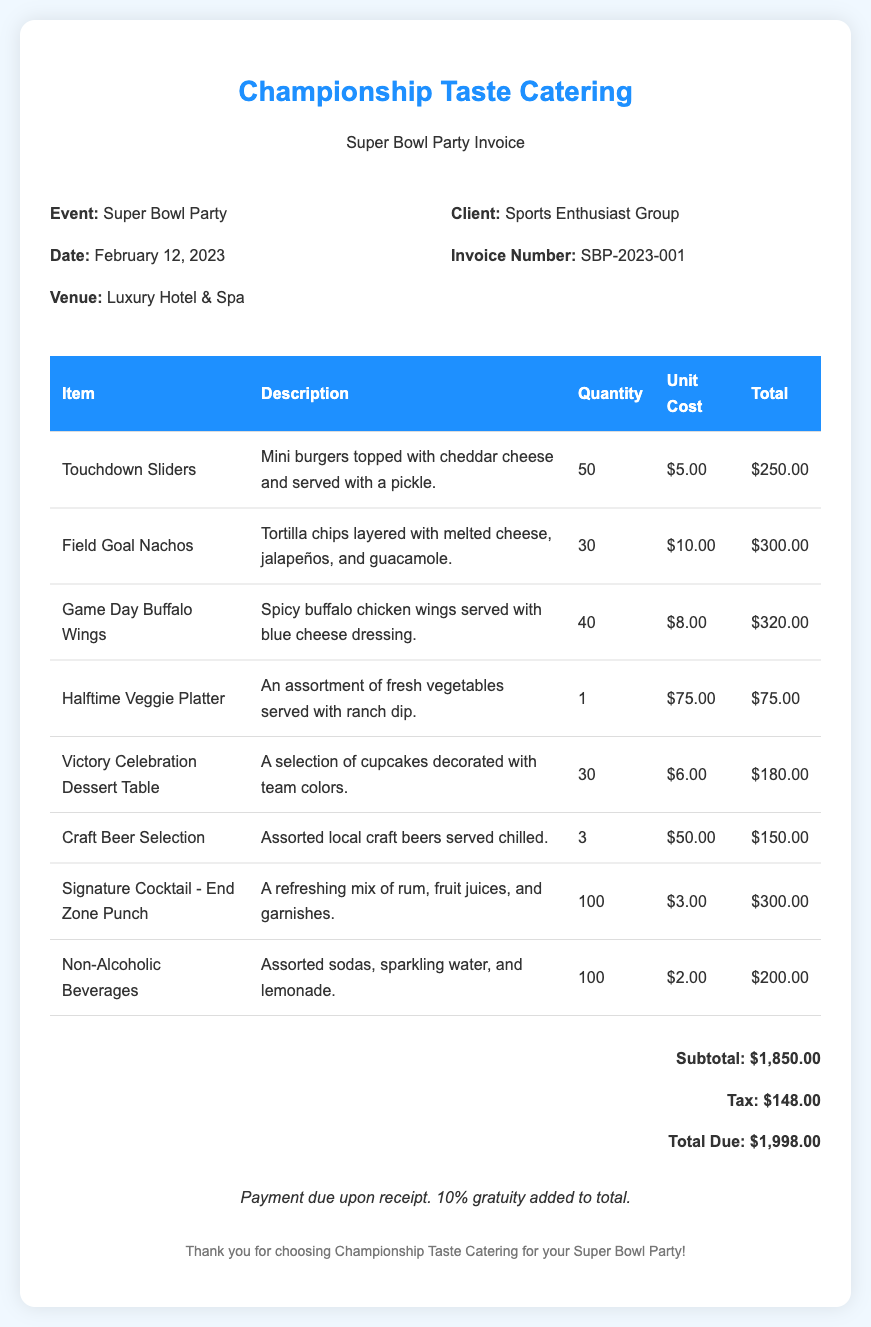What is the event date? The event date is specified in the document under the event details.
Answer: February 12, 2023 Who is the client? The client's name is provided in the invoice details section.
Answer: Sports Enthusiast Group What is the invoice number? The invoice number is mentioned explicitly within the invoice.
Answer: SBP-2023-001 What item has the highest unit cost? To find this, we compare the unit costs of all items listed.
Answer: Halftime Veggie Platter What is the total due? The total due is clearly stated in the total section of the invoice.
Answer: $1,998.00 How many servings of Touchdown Sliders were provided? The quantity for Touchdown Sliders is noted in the food items table.
Answer: 50 What is the subtotal before tax? The subtotal is presented as part of the invoice totals.
Answer: $1,850.00 Which drink item had the largest quantity ordered? By comparing quantities of drink items, we see which one is larger.
Answer: Signature Cocktail - End Zone Punch Is a gratuity included in the total? The terms mention gratuity in relation to the total.
Answer: Yes 